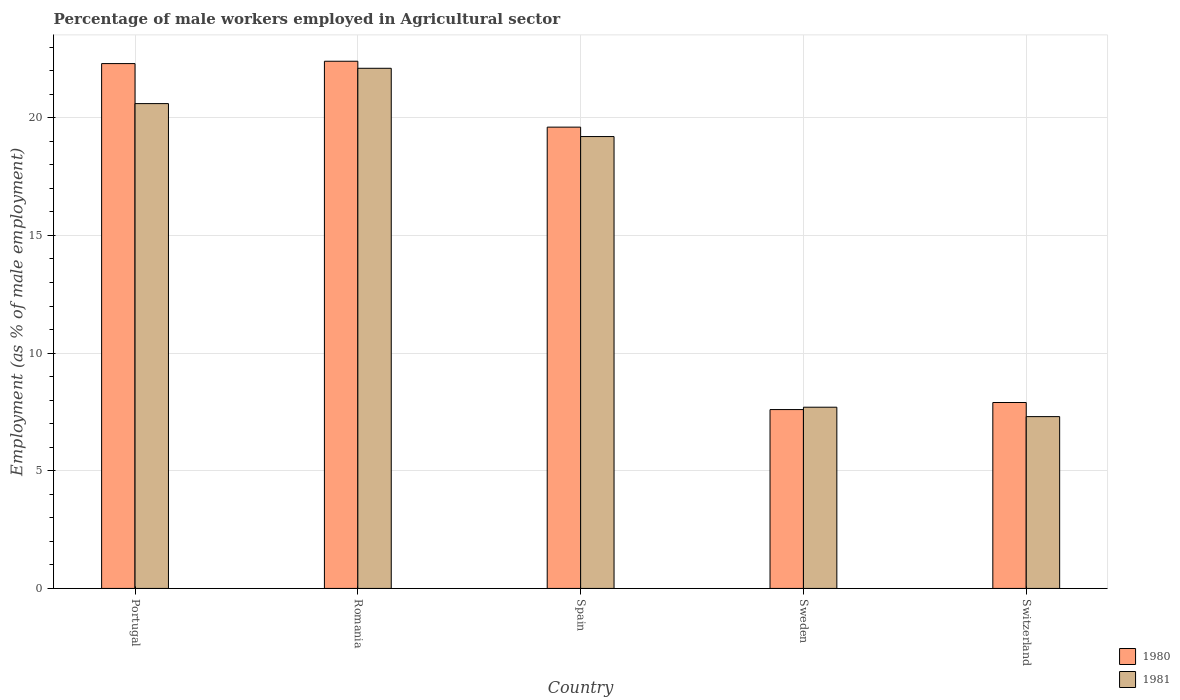How many different coloured bars are there?
Keep it short and to the point. 2. Are the number of bars on each tick of the X-axis equal?
Offer a terse response. Yes. How many bars are there on the 4th tick from the right?
Your response must be concise. 2. What is the label of the 2nd group of bars from the left?
Your answer should be very brief. Romania. What is the percentage of male workers employed in Agricultural sector in 1981 in Switzerland?
Provide a succinct answer. 7.3. Across all countries, what is the maximum percentage of male workers employed in Agricultural sector in 1980?
Offer a very short reply. 22.4. Across all countries, what is the minimum percentage of male workers employed in Agricultural sector in 1980?
Offer a very short reply. 7.6. In which country was the percentage of male workers employed in Agricultural sector in 1981 maximum?
Your answer should be compact. Romania. In which country was the percentage of male workers employed in Agricultural sector in 1980 minimum?
Your response must be concise. Sweden. What is the total percentage of male workers employed in Agricultural sector in 1980 in the graph?
Ensure brevity in your answer.  79.8. What is the difference between the percentage of male workers employed in Agricultural sector in 1980 in Portugal and that in Sweden?
Make the answer very short. 14.7. What is the difference between the percentage of male workers employed in Agricultural sector in 1980 in Sweden and the percentage of male workers employed in Agricultural sector in 1981 in Switzerland?
Your answer should be compact. 0.3. What is the average percentage of male workers employed in Agricultural sector in 1981 per country?
Keep it short and to the point. 15.38. What is the difference between the percentage of male workers employed in Agricultural sector of/in 1981 and percentage of male workers employed in Agricultural sector of/in 1980 in Portugal?
Provide a succinct answer. -1.7. What is the ratio of the percentage of male workers employed in Agricultural sector in 1980 in Portugal to that in Romania?
Ensure brevity in your answer.  1. Is the percentage of male workers employed in Agricultural sector in 1980 in Portugal less than that in Sweden?
Ensure brevity in your answer.  No. What is the difference between the highest and the second highest percentage of male workers employed in Agricultural sector in 1981?
Your answer should be very brief. -1.4. What is the difference between the highest and the lowest percentage of male workers employed in Agricultural sector in 1980?
Offer a terse response. 14.8. What does the 1st bar from the left in Switzerland represents?
Provide a short and direct response. 1980. What does the 2nd bar from the right in Switzerland represents?
Ensure brevity in your answer.  1980. What is the difference between two consecutive major ticks on the Y-axis?
Make the answer very short. 5. Are the values on the major ticks of Y-axis written in scientific E-notation?
Ensure brevity in your answer.  No. Does the graph contain any zero values?
Give a very brief answer. No. Where does the legend appear in the graph?
Your answer should be compact. Bottom right. How many legend labels are there?
Offer a very short reply. 2. How are the legend labels stacked?
Ensure brevity in your answer.  Vertical. What is the title of the graph?
Your answer should be very brief. Percentage of male workers employed in Agricultural sector. Does "1996" appear as one of the legend labels in the graph?
Keep it short and to the point. No. What is the label or title of the X-axis?
Your answer should be compact. Country. What is the label or title of the Y-axis?
Provide a succinct answer. Employment (as % of male employment). What is the Employment (as % of male employment) of 1980 in Portugal?
Give a very brief answer. 22.3. What is the Employment (as % of male employment) of 1981 in Portugal?
Ensure brevity in your answer.  20.6. What is the Employment (as % of male employment) in 1980 in Romania?
Make the answer very short. 22.4. What is the Employment (as % of male employment) in 1981 in Romania?
Your answer should be compact. 22.1. What is the Employment (as % of male employment) of 1980 in Spain?
Keep it short and to the point. 19.6. What is the Employment (as % of male employment) in 1981 in Spain?
Your response must be concise. 19.2. What is the Employment (as % of male employment) in 1980 in Sweden?
Your answer should be very brief. 7.6. What is the Employment (as % of male employment) of 1981 in Sweden?
Make the answer very short. 7.7. What is the Employment (as % of male employment) of 1980 in Switzerland?
Provide a short and direct response. 7.9. What is the Employment (as % of male employment) in 1981 in Switzerland?
Provide a succinct answer. 7.3. Across all countries, what is the maximum Employment (as % of male employment) of 1980?
Ensure brevity in your answer.  22.4. Across all countries, what is the maximum Employment (as % of male employment) of 1981?
Ensure brevity in your answer.  22.1. Across all countries, what is the minimum Employment (as % of male employment) of 1980?
Your answer should be compact. 7.6. Across all countries, what is the minimum Employment (as % of male employment) of 1981?
Offer a very short reply. 7.3. What is the total Employment (as % of male employment) in 1980 in the graph?
Provide a short and direct response. 79.8. What is the total Employment (as % of male employment) of 1981 in the graph?
Offer a terse response. 76.9. What is the difference between the Employment (as % of male employment) of 1981 in Portugal and that in Romania?
Your answer should be very brief. -1.5. What is the difference between the Employment (as % of male employment) of 1980 in Portugal and that in Sweden?
Offer a terse response. 14.7. What is the difference between the Employment (as % of male employment) in 1981 in Portugal and that in Sweden?
Provide a short and direct response. 12.9. What is the difference between the Employment (as % of male employment) in 1981 in Romania and that in Spain?
Provide a short and direct response. 2.9. What is the difference between the Employment (as % of male employment) of 1981 in Romania and that in Sweden?
Your answer should be compact. 14.4. What is the difference between the Employment (as % of male employment) in 1981 in Romania and that in Switzerland?
Offer a terse response. 14.8. What is the difference between the Employment (as % of male employment) of 1981 in Spain and that in Sweden?
Your answer should be compact. 11.5. What is the difference between the Employment (as % of male employment) in 1980 in Sweden and that in Switzerland?
Provide a short and direct response. -0.3. What is the difference between the Employment (as % of male employment) of 1980 in Portugal and the Employment (as % of male employment) of 1981 in Romania?
Your answer should be very brief. 0.2. What is the difference between the Employment (as % of male employment) in 1980 in Portugal and the Employment (as % of male employment) in 1981 in Spain?
Provide a succinct answer. 3.1. What is the difference between the Employment (as % of male employment) in 1980 in Portugal and the Employment (as % of male employment) in 1981 in Sweden?
Give a very brief answer. 14.6. What is the difference between the Employment (as % of male employment) in 1980 in Romania and the Employment (as % of male employment) in 1981 in Switzerland?
Provide a short and direct response. 15.1. What is the difference between the Employment (as % of male employment) in 1980 in Spain and the Employment (as % of male employment) in 1981 in Sweden?
Offer a terse response. 11.9. What is the average Employment (as % of male employment) in 1980 per country?
Your answer should be very brief. 15.96. What is the average Employment (as % of male employment) in 1981 per country?
Give a very brief answer. 15.38. What is the difference between the Employment (as % of male employment) of 1980 and Employment (as % of male employment) of 1981 in Portugal?
Your answer should be very brief. 1.7. What is the difference between the Employment (as % of male employment) of 1980 and Employment (as % of male employment) of 1981 in Spain?
Your answer should be very brief. 0.4. What is the ratio of the Employment (as % of male employment) in 1981 in Portugal to that in Romania?
Provide a short and direct response. 0.93. What is the ratio of the Employment (as % of male employment) of 1980 in Portugal to that in Spain?
Provide a short and direct response. 1.14. What is the ratio of the Employment (as % of male employment) in 1981 in Portugal to that in Spain?
Your answer should be very brief. 1.07. What is the ratio of the Employment (as % of male employment) in 1980 in Portugal to that in Sweden?
Offer a very short reply. 2.93. What is the ratio of the Employment (as % of male employment) of 1981 in Portugal to that in Sweden?
Make the answer very short. 2.68. What is the ratio of the Employment (as % of male employment) of 1980 in Portugal to that in Switzerland?
Offer a very short reply. 2.82. What is the ratio of the Employment (as % of male employment) in 1981 in Portugal to that in Switzerland?
Your response must be concise. 2.82. What is the ratio of the Employment (as % of male employment) of 1980 in Romania to that in Spain?
Ensure brevity in your answer.  1.14. What is the ratio of the Employment (as % of male employment) in 1981 in Romania to that in Spain?
Make the answer very short. 1.15. What is the ratio of the Employment (as % of male employment) of 1980 in Romania to that in Sweden?
Provide a short and direct response. 2.95. What is the ratio of the Employment (as % of male employment) in 1981 in Romania to that in Sweden?
Provide a succinct answer. 2.87. What is the ratio of the Employment (as % of male employment) of 1980 in Romania to that in Switzerland?
Ensure brevity in your answer.  2.84. What is the ratio of the Employment (as % of male employment) of 1981 in Romania to that in Switzerland?
Provide a short and direct response. 3.03. What is the ratio of the Employment (as % of male employment) of 1980 in Spain to that in Sweden?
Keep it short and to the point. 2.58. What is the ratio of the Employment (as % of male employment) in 1981 in Spain to that in Sweden?
Your response must be concise. 2.49. What is the ratio of the Employment (as % of male employment) of 1980 in Spain to that in Switzerland?
Provide a short and direct response. 2.48. What is the ratio of the Employment (as % of male employment) in 1981 in Spain to that in Switzerland?
Your answer should be compact. 2.63. What is the ratio of the Employment (as % of male employment) in 1980 in Sweden to that in Switzerland?
Ensure brevity in your answer.  0.96. What is the ratio of the Employment (as % of male employment) in 1981 in Sweden to that in Switzerland?
Provide a short and direct response. 1.05. What is the difference between the highest and the second highest Employment (as % of male employment) in 1980?
Provide a succinct answer. 0.1. What is the difference between the highest and the lowest Employment (as % of male employment) of 1981?
Your answer should be very brief. 14.8. 